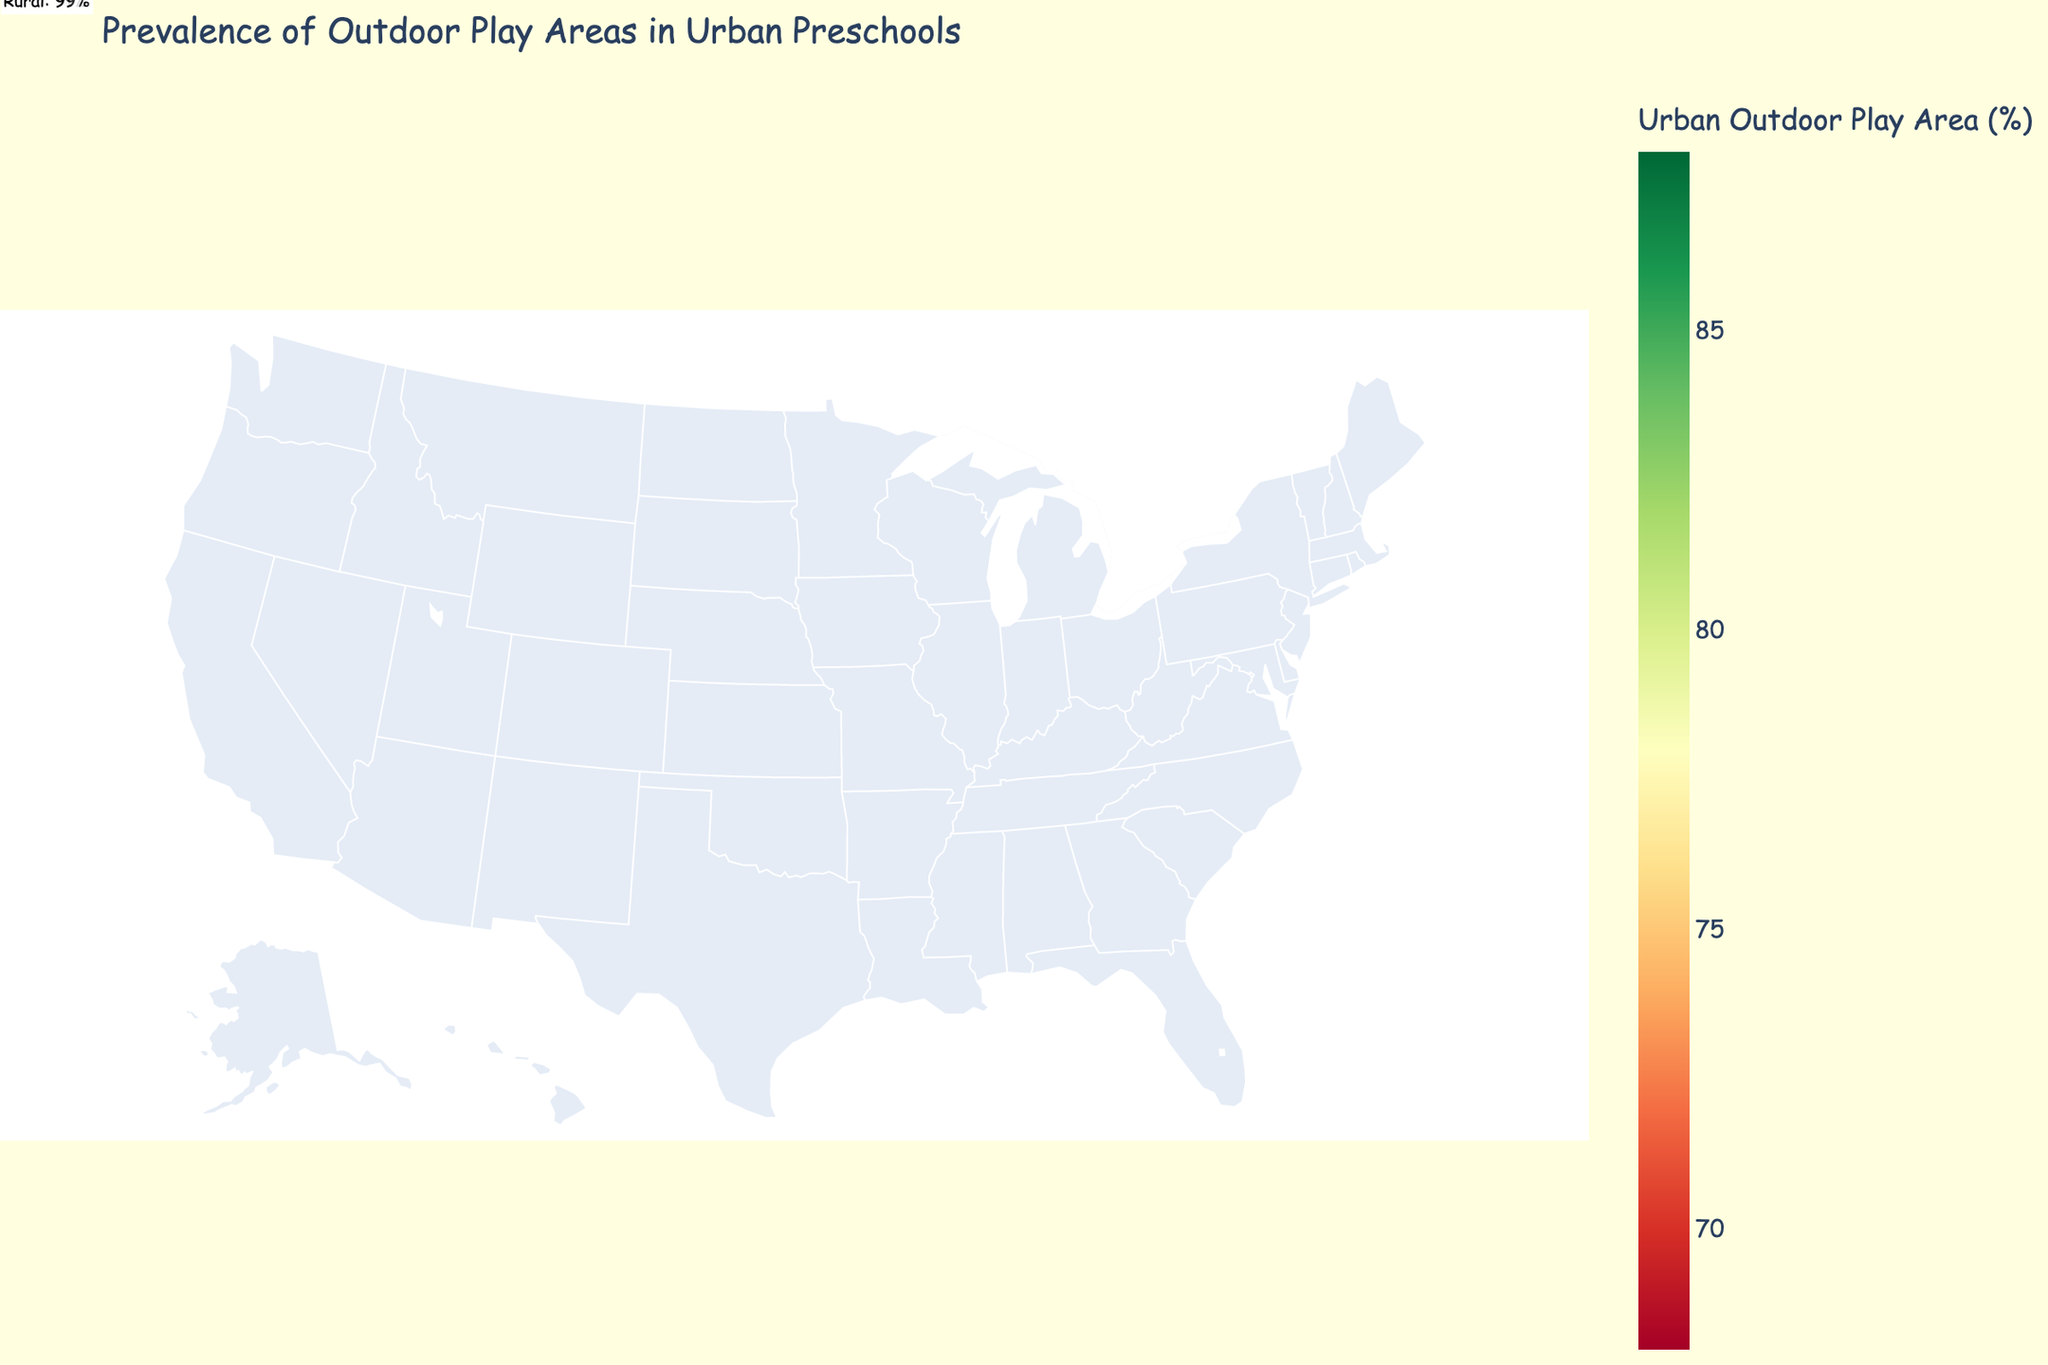What's the title of the figure? The title of the figure appears at the top and provides a description of what the figure represents.
Answer: Prevalence of Outdoor Play Areas in Urban Preschools Which region has the highest percentage of urban outdoor play areas? By analyzing the color scale and the annotation, the region with the darkest color in the urban data represents the highest percentage.
Answer: Southwest Which region has the lowest percentage of urban outdoor play areas? By examining the color scale and annotations, look for the lightest color in the urban data.
Answer: New England What is the difference in urban outdoor play area percentage between the Southwest and New England regions? Refer to the values for both regions: Southwest (88%) - New England (68%). The difference can be calculated by subtracting the smaller value from the larger value.
Answer: 20% Which regions have a higher percentage of urban outdoor play areas compared to California? Identify regions with urban outdoor play area percentages higher than California's 82%. These values must be higher when examined in the map.
Answer: Southeast, Southwest, Hawaii, Great Plains What is the average percentage of urban outdoor play areas across all regions? Sum all urban outdoor play area percentages and divide by the number of regions: (68 + 72 + 85 + 79 + 88 + 76 + 82 + 70 + 84 + 81) / 10. The average is calculated by this formula.
Answer: 78.5% Which regions have a smaller percentage of urban outdoor play areas than rural ones? By examining the annotations for rural data, compare it with the urban data for all regions. It shows that all urban percentages are smaller than their rural counterparts.
Answer: All regions How much higher is the rural play area percentage in Great Plains compared to the urban play area percentage? Subtract the urban percentage for Great Plains from the rural percentage: 99% - 81%.
Answer: 18% Which region has identical percentages or close to identical (smallest difference) for both urban and rural outdoor play areas? Examine the annotations and urban values to find the smallest difference: New England (24%). Check all regions manually if no exact match exists.
Answer: Hawaii What does the annotation represent? Each annotation shows the percentage of rural outdoor play areas for the corresponding region on the map.
Answer: Rural Outdoor Play Area Percentage 